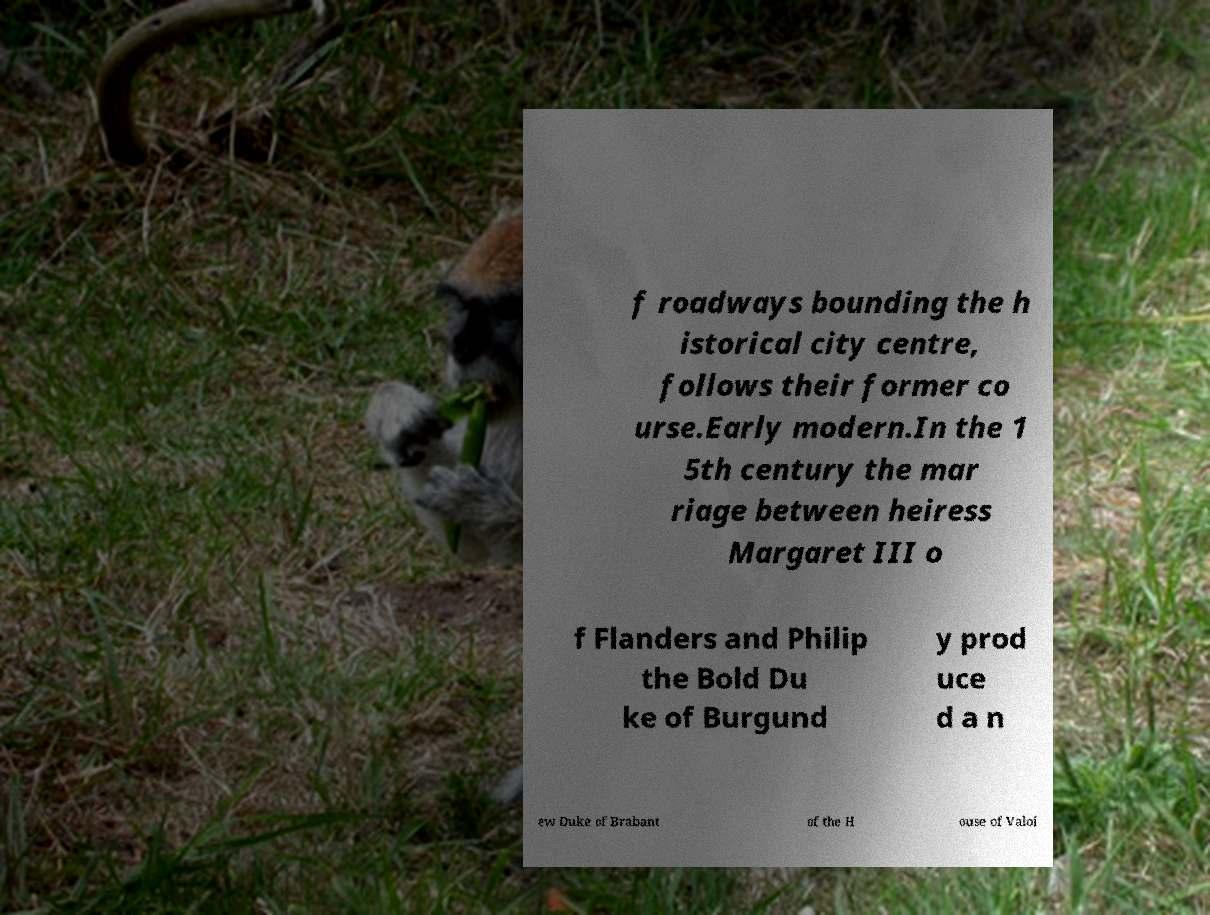Please identify and transcribe the text found in this image. f roadways bounding the h istorical city centre, follows their former co urse.Early modern.In the 1 5th century the mar riage between heiress Margaret III o f Flanders and Philip the Bold Du ke of Burgund y prod uce d a n ew Duke of Brabant of the H ouse of Valoi 